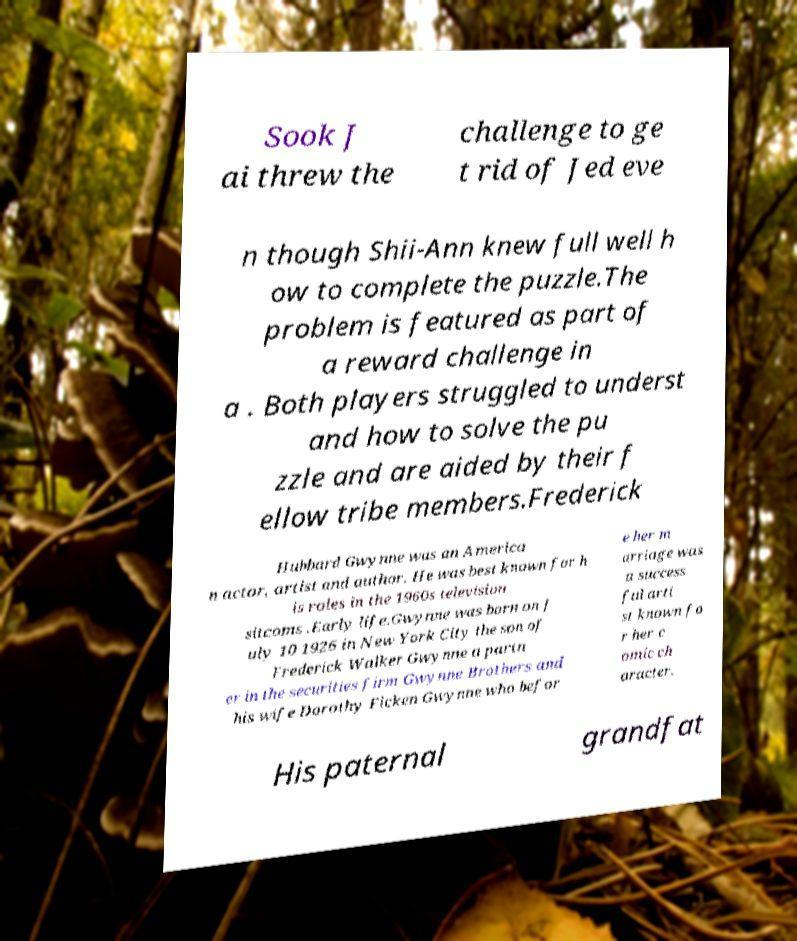Could you assist in decoding the text presented in this image and type it out clearly? Sook J ai threw the challenge to ge t rid of Jed eve n though Shii-Ann knew full well h ow to complete the puzzle.The problem is featured as part of a reward challenge in a . Both players struggled to underst and how to solve the pu zzle and are aided by their f ellow tribe members.Frederick Hubbard Gwynne was an America n actor, artist and author. He was best known for h is roles in the 1960s television sitcoms .Early life.Gwynne was born on J uly 10 1926 in New York City the son of Frederick Walker Gwynne a partn er in the securities firm Gwynne Brothers and his wife Dorothy Ficken Gwynne who befor e her m arriage was a success ful arti st known fo r her c omic ch aracter. His paternal grandfat 